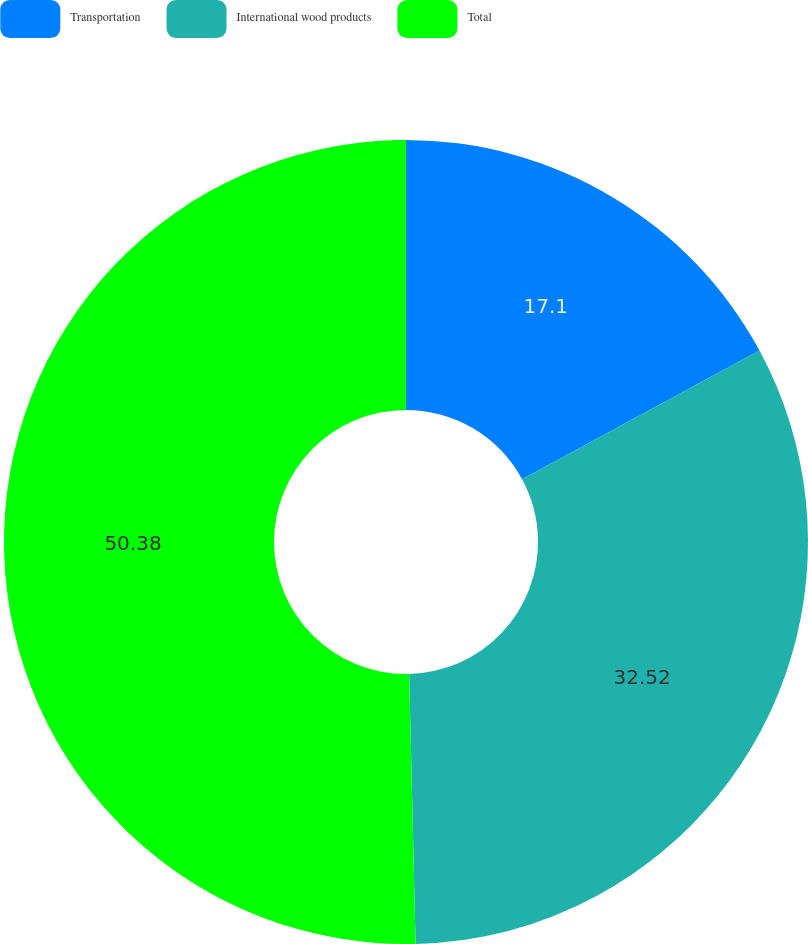<chart> <loc_0><loc_0><loc_500><loc_500><pie_chart><fcel>Transportation<fcel>International wood products<fcel>Total<nl><fcel>17.1%<fcel>32.52%<fcel>50.38%<nl></chart> 